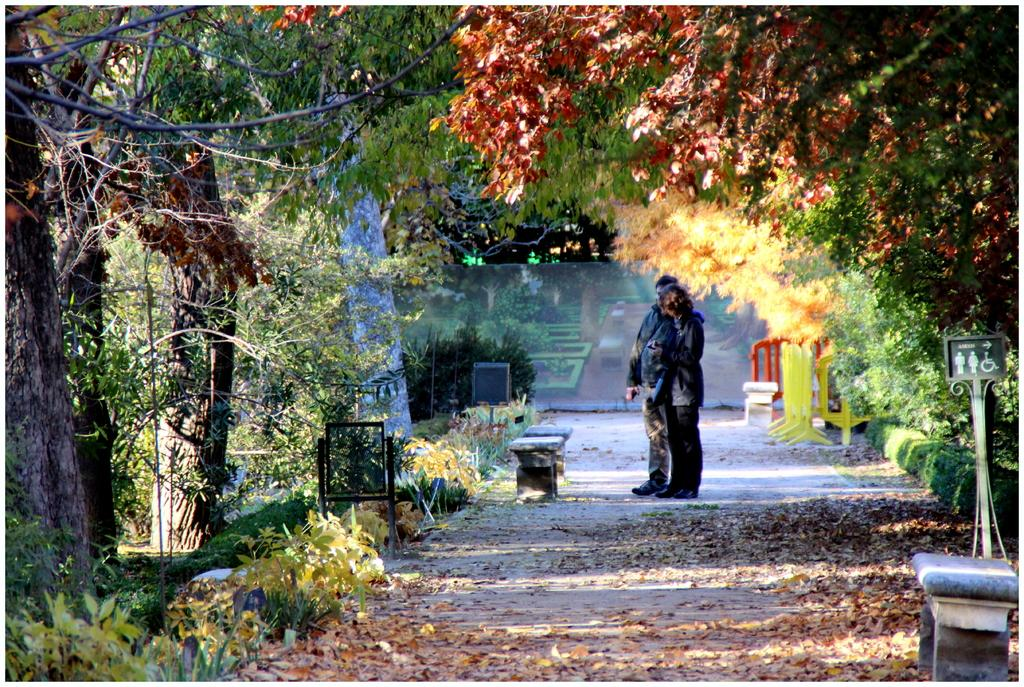How many people are in the image? There are two persons standing in the image. What can be seen in the background of the image? There are benches, trees, and plants in the image. What is present on the ground in the image? Dried leaves are present on the road in the image. What type of pest can be seen crawling on the benches in the image? There is no pest visible on the benches in the image. What is the title of the book the person is holding in the image? There is no book present in the image, so it is not possible to determine the title. 